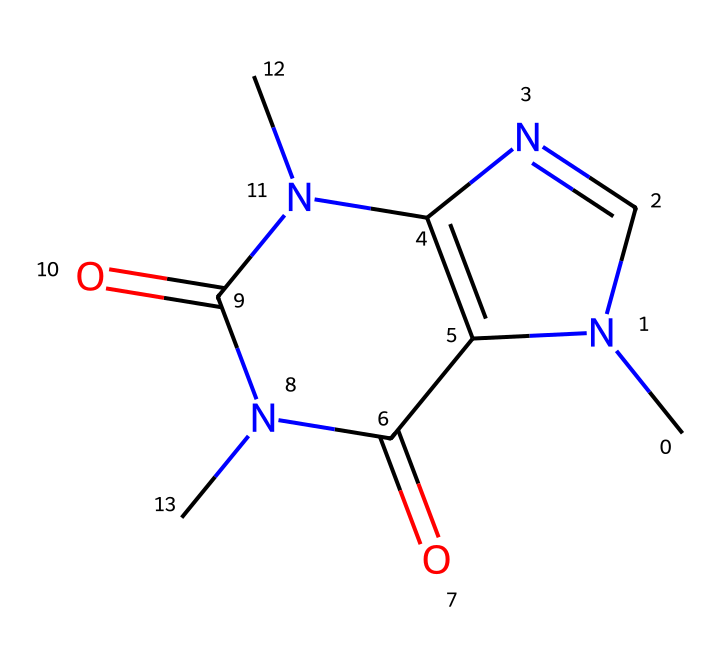how many nitrogen atoms are present in the structure? By examining the SMILES representation, there are two distinct nitrogen atoms indicated by 'N'. This is counted directly from the text, which shows 'N' appearing twice.
Answer: two what is the main functional group in caffeine? The structure of caffeine contains several functional groups, but the primary one is the imide functional group, which arises from the nitrogen attached to the carbonyl group (C=O).
Answer: imide how many rings are in the chemical structure? The chemical structure of caffeine has two interconnected rings, which can be visualized in its structural representation. This is based on the two cyclic portions formed from the carbon and nitrogen atoms.
Answer: two what type of chemical is caffeine classified as? Caffeine is classified as an alkaloid, which is a group of naturally occurring organic compounds that mostly contain basic nitrogen atoms. The presence of nitrogen and its effects on the body are characteristic of alkaloids.
Answer: alkaloid what is the total number of carbon atoms in the structure? In the SMILES representation, counting the 'C' letters reveals there are eight carbon atoms present in the chemical structure of caffeine. Each 'C' represents a carbon atom.
Answer: eight what are the main effects of caffeine on the human body? Caffeine primarily acts as a stimulant, enhancing alertness and reducing fatigue. This is based on its chemical properties, including its ability to block adenosine receptors in the brain.
Answer: stimulant 